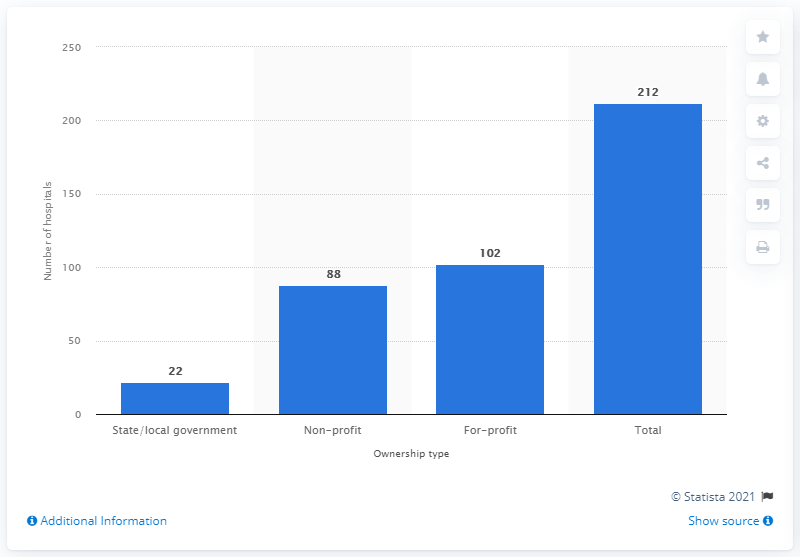Outline some significant characteristics in this image. In 2019, there were 212 hospitals in the state of Florida. 